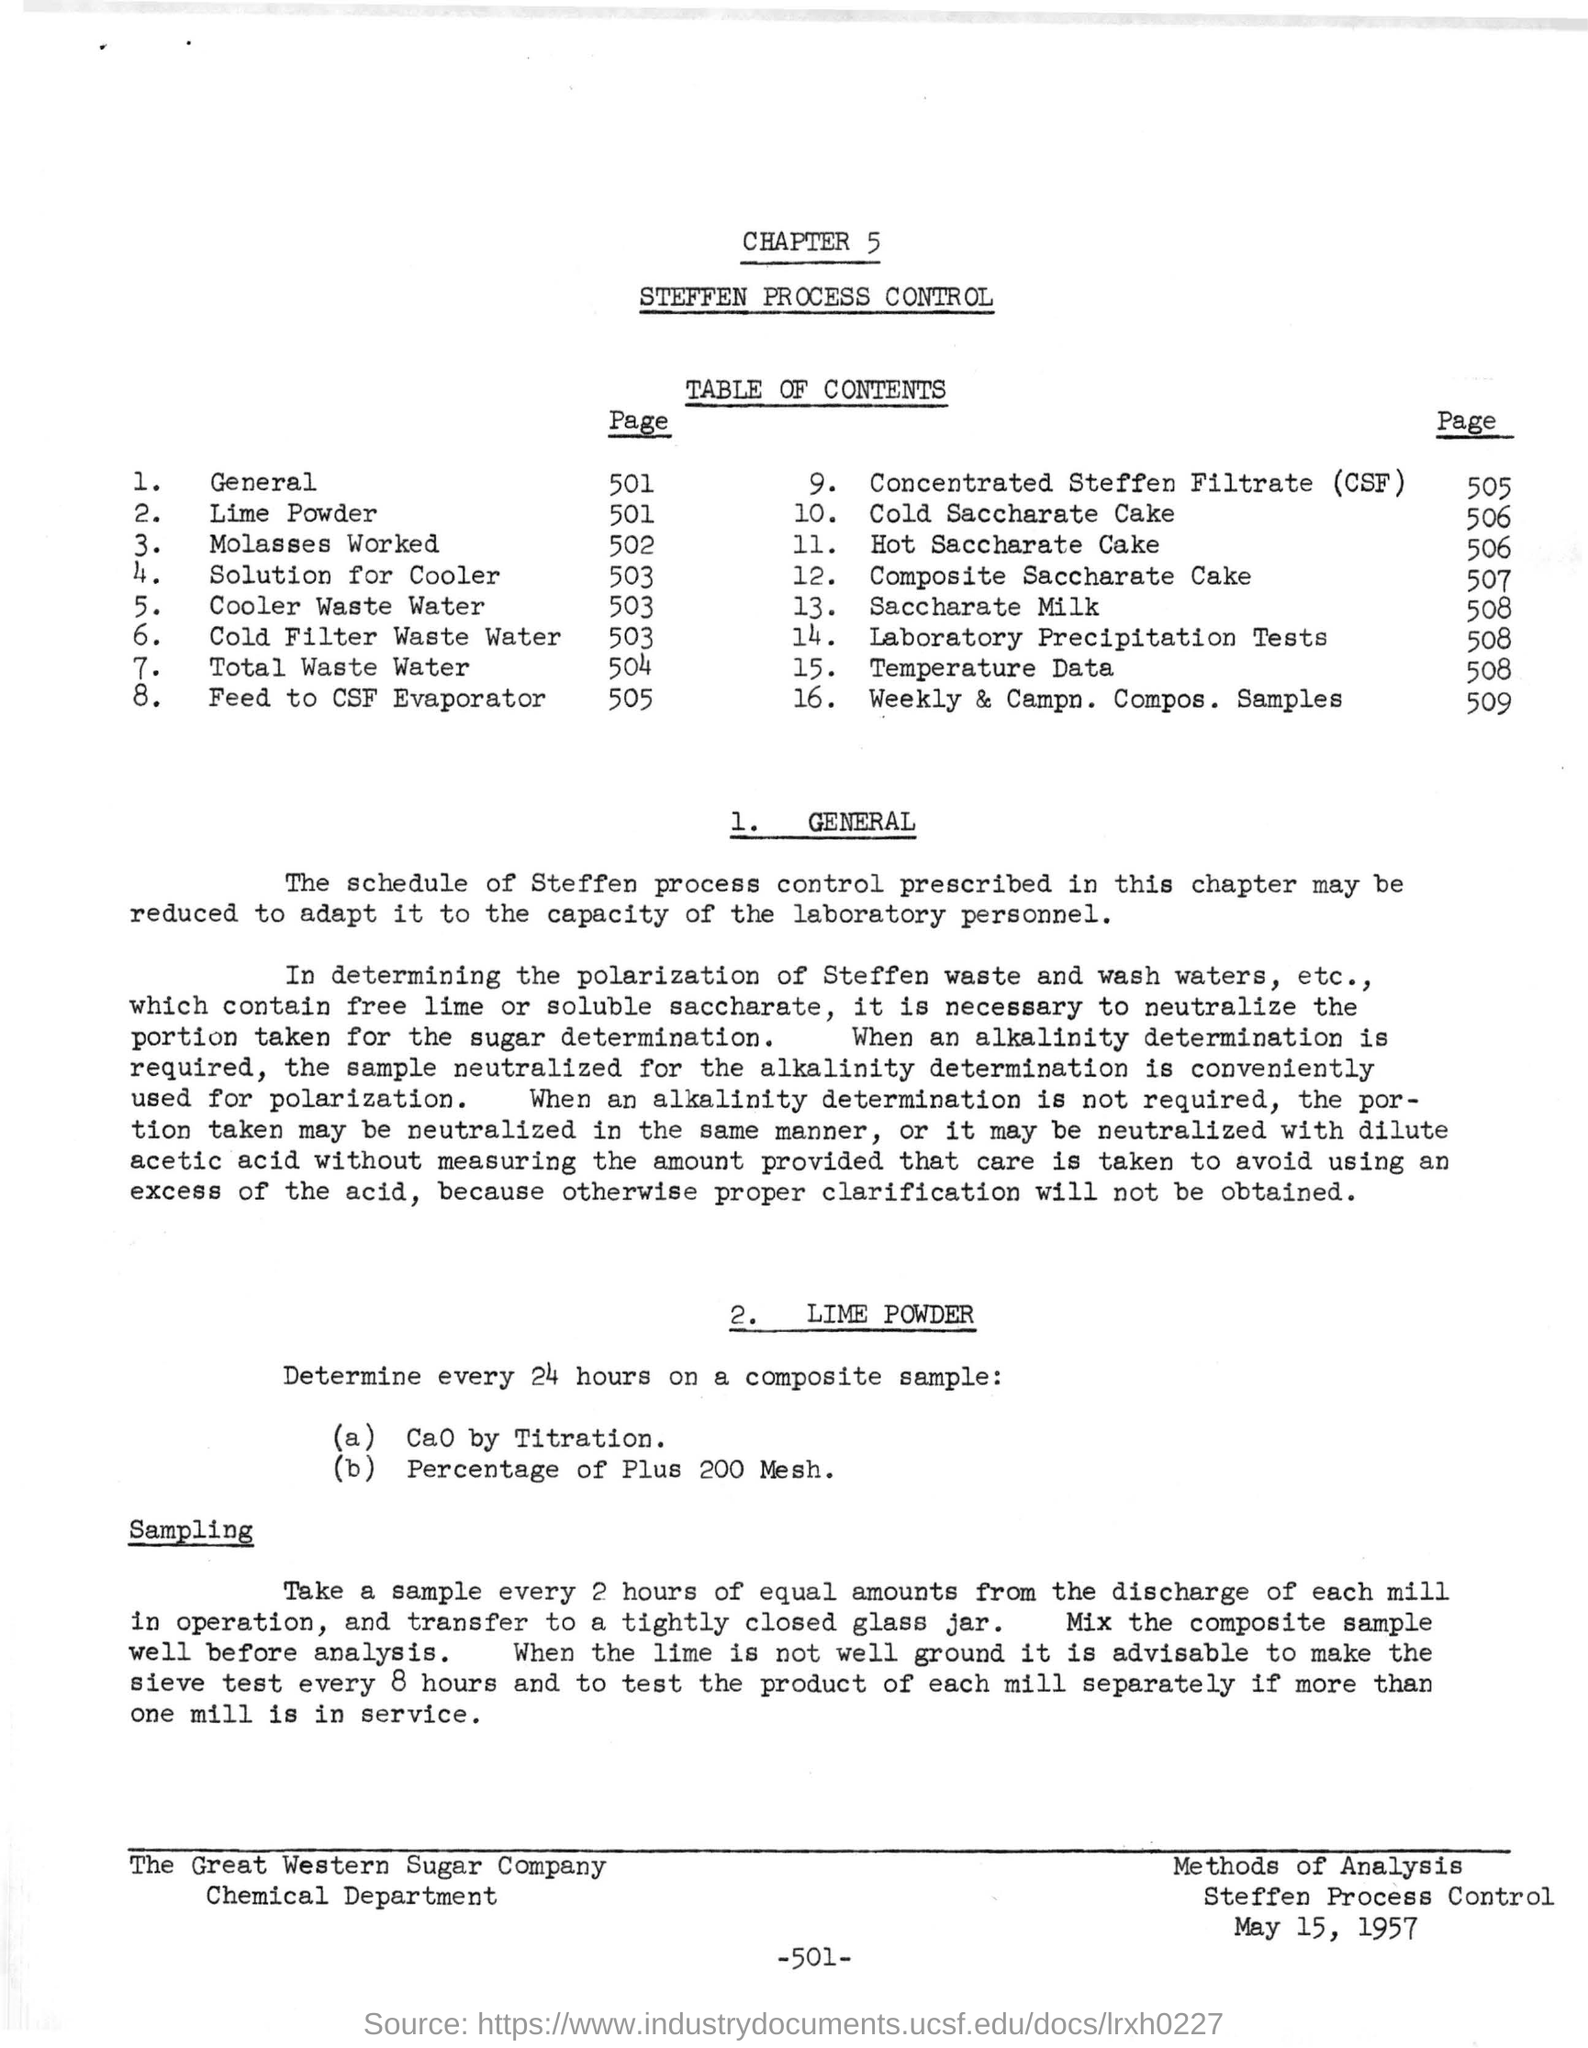What is the title of chapter 5?
Provide a succinct answer. Steffen Process Control. On which page is Laboratory Precipitation Tests?
Give a very brief answer. 508. When is the document dated?
Give a very brief answer. May 15, 1957. What should be determined every 24 hours on a composite sample?
Keep it short and to the point. (a) CaO by Titration. (b) Percentage of Plus 200 Mesh. 